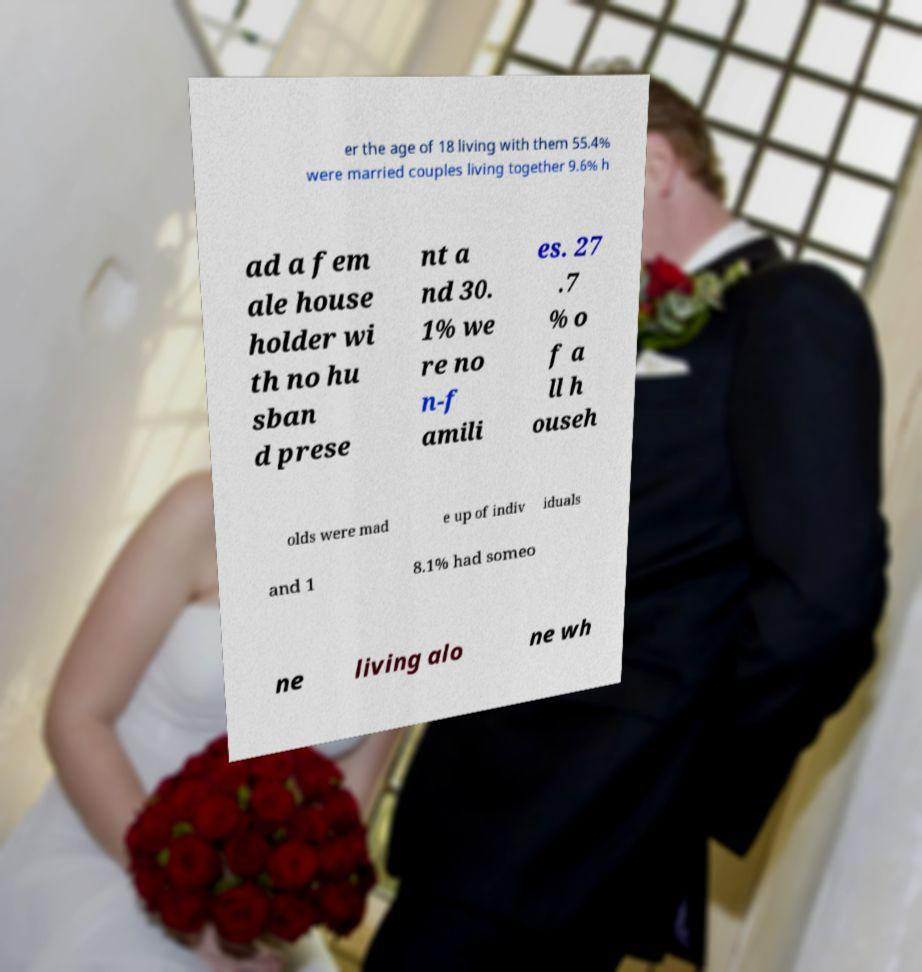I need the written content from this picture converted into text. Can you do that? er the age of 18 living with them 55.4% were married couples living together 9.6% h ad a fem ale house holder wi th no hu sban d prese nt a nd 30. 1% we re no n-f amili es. 27 .7 % o f a ll h ouseh olds were mad e up of indiv iduals and 1 8.1% had someo ne living alo ne wh 